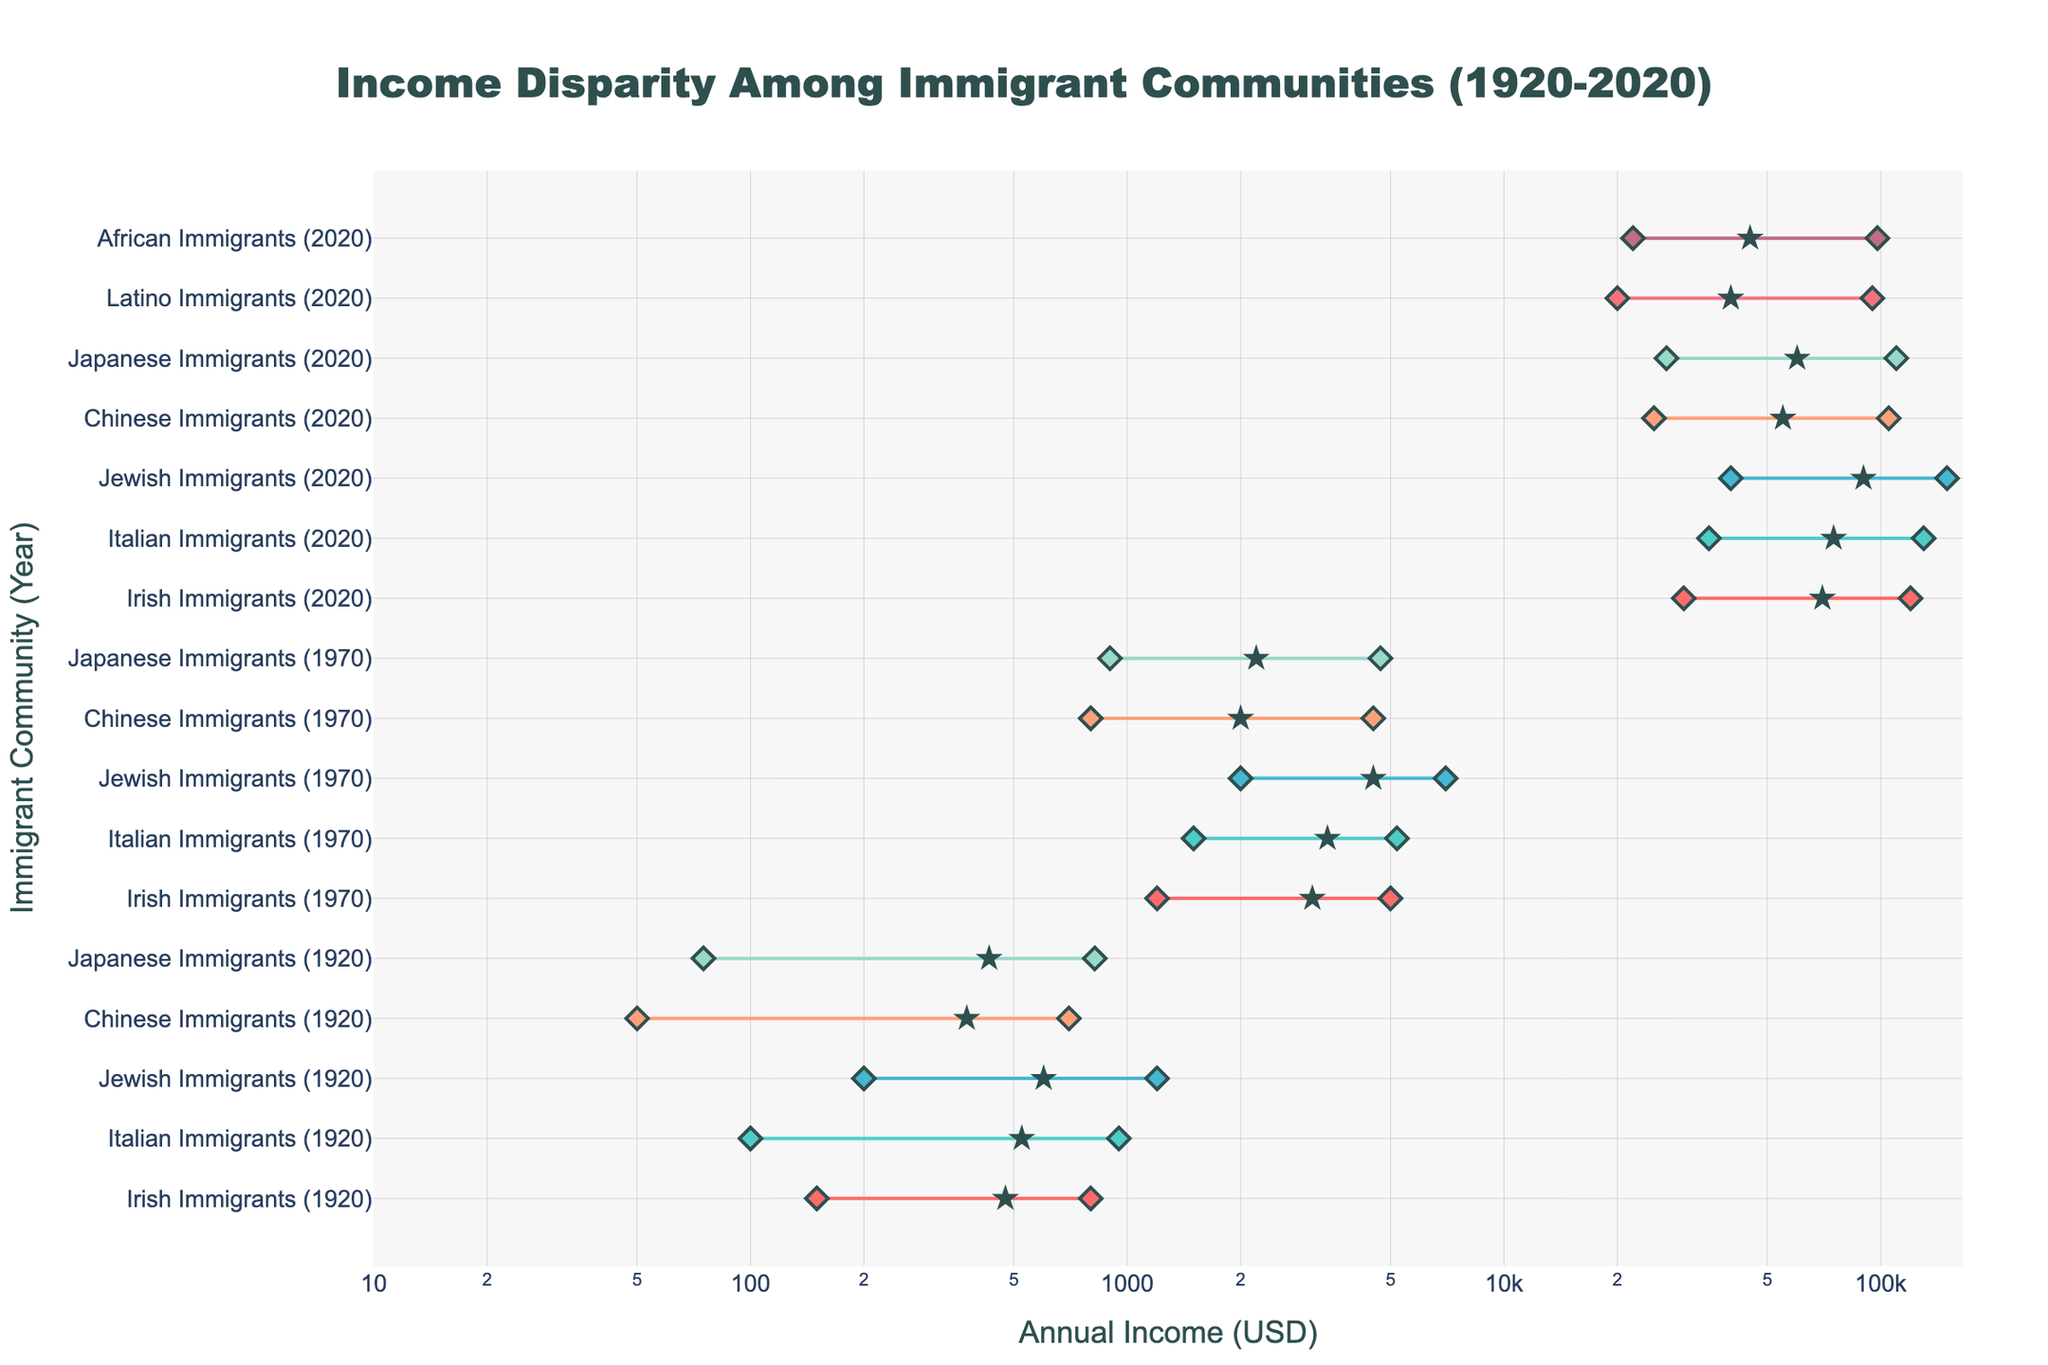What is the median income of Jewish Immigrants in 2020? From the visual, locate the data point labeled *Jewish Immigrants (2020)* and identify the central marker, which represents the median income.
Answer: 90,000 How much did the maximum income of Italian Immigrants change from 1920 to 2020? Identify the maximum income markers for *Italian Immigrants* in 1920 and 2020, respectively. The change is the difference between these two values (130,000 - 950).
Answer: 129,050 Which community had the lowest minimum income in 1920? Look for the lowest point among the minimum income markers for all communities in 1920.
Answer: Chinese Immigrants Compare the income range of Chinese Immigrants and Irish Immigrants in 1970. Who had a larger range? Calculate the income range for both communities in 1970 by subtracting the minimum income from the maximum income. Irish: (5000 - 1200) = 3800, Chinese: (4500 - 800) = 3700. Compare these values.
Answer: Irish Immigrants What is the median income of Japanese Immigrants in 1970 compared to their median income in 2020? For both years, locate the central star markers for *Japanese Immigrants*. In 1970 it is 2,200, and in 2020 it is 60,000.
Answer: 2,200 in 1970; 60,000 in 2020 Did any new communities appear in the 2020 data that were not present in 1920? Compare the list of communities in 1920 and 2020. Identify any additional communities listed in 2020.
Answer: Latino and African Immigrants What was the income disparity (difference between maximum and minimum income) for Jewish Immigrants in 1920? Locate the data points for Jewish Immigrants in 1920, and subtract the minimum income from the maximum income (1200 - 200).
Answer: 1,000 Which immigrant community had the highest median income in 1920? Identify the community with the highest central marker (star) of those listed in 1920.
Answer: Jewish Immigrants How did the median income of Chinese Immigrants change from 1970 to 2020? Locate and compare the central median markers for *Chinese Immigrants* in 1970 (2,000) and 2020 (55,000). Subtract the earlier median from the later one. (55,000 - 2,000)
Answer: 53,000 What is the range of median incomes among all immigrant communities in 2020? Identify the highest and lowest median income markers among all communities listed. Subtract the lowest median income from the highest median income (90,000 - 40,000).
Answer: 50,000 